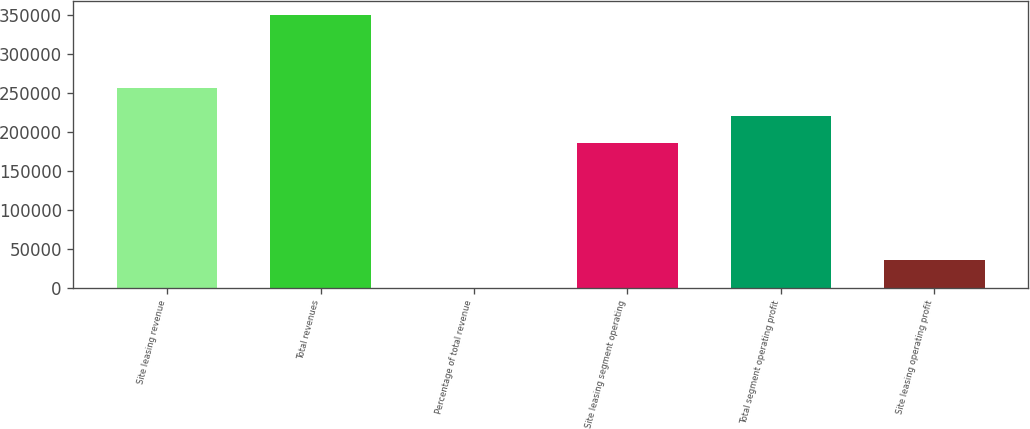<chart> <loc_0><loc_0><loc_500><loc_500><bar_chart><fcel>Site leasing revenue<fcel>Total revenues<fcel>Percentage of total revenue<fcel>Site leasing segment operating<fcel>Total segment operating profit<fcel>Site leasing operating profit<nl><fcel>256170<fcel>351102<fcel>73<fcel>185507<fcel>220610<fcel>35175.9<nl></chart> 